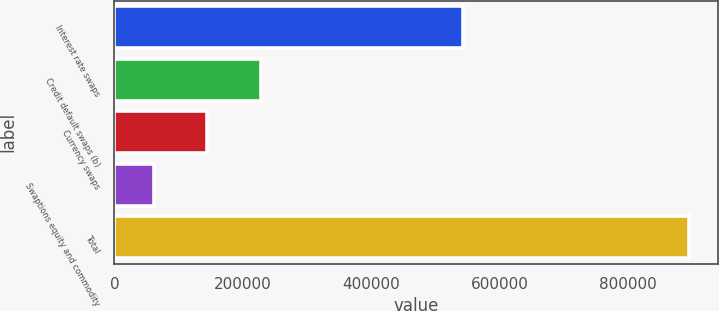<chart> <loc_0><loc_0><loc_500><loc_500><bar_chart><fcel>Interest rate swaps<fcel>Credit default swaps (b)<fcel>Currency swaps<fcel>Swaptions equity and commodity<fcel>Total<nl><fcel>542810<fcel>227791<fcel>144395<fcel>60998<fcel>894964<nl></chart> 